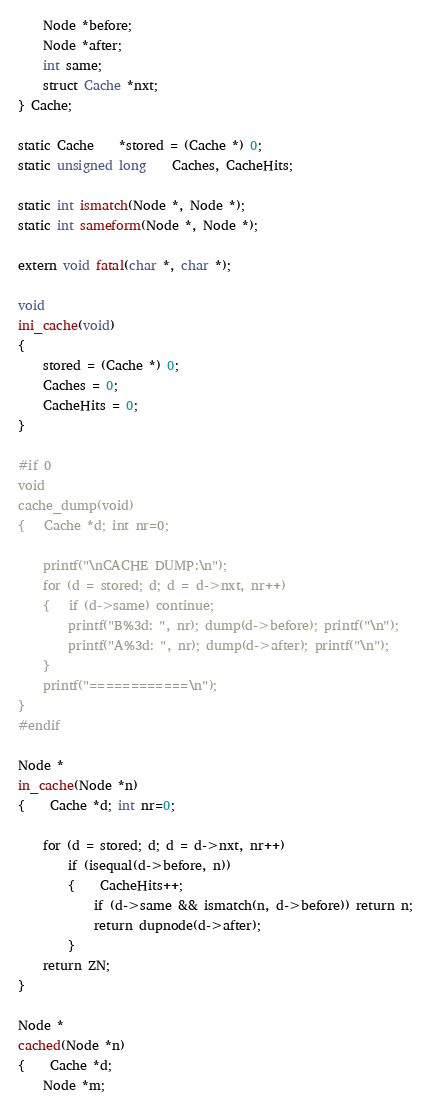Convert code to text. <code><loc_0><loc_0><loc_500><loc_500><_C_>	Node *before;
	Node *after;
	int same;
	struct Cache *nxt;
} Cache;

static Cache	*stored = (Cache *) 0;
static unsigned long	Caches, CacheHits;

static int ismatch(Node *, Node *);
static int sameform(Node *, Node *);

extern void fatal(char *, char *);

void
ini_cache(void)
{
	stored = (Cache *) 0;
	Caches = 0;
	CacheHits = 0;
}

#if 0
void
cache_dump(void)
{	Cache *d; int nr=0;

	printf("\nCACHE DUMP:\n");
	for (d = stored; d; d = d->nxt, nr++)
	{	if (d->same) continue;
		printf("B%3d: ", nr); dump(d->before); printf("\n");
		printf("A%3d: ", nr); dump(d->after); printf("\n");
	}
	printf("============\n");
}
#endif

Node *
in_cache(Node *n)
{	Cache *d; int nr=0;

	for (d = stored; d; d = d->nxt, nr++)
		if (isequal(d->before, n))
		{	CacheHits++;
			if (d->same && ismatch(n, d->before)) return n;
			return dupnode(d->after);
		}
	return ZN;
}

Node *
cached(Node *n)
{	Cache *d;
	Node *m;
</code> 